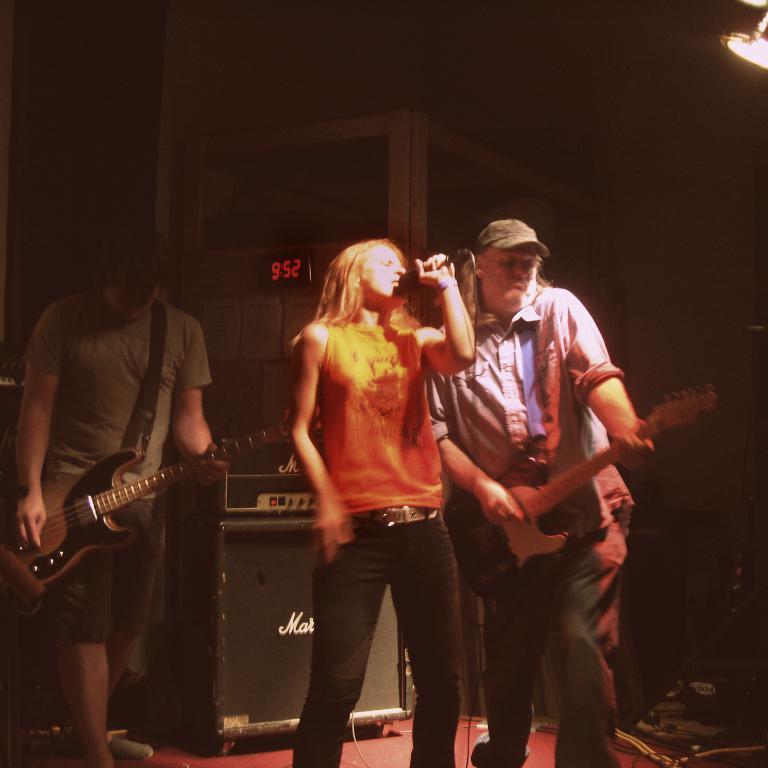Please provide a concise description of this image. There are three members in this picture. Two of them were men who are playing guitars in their hands and the another one is woman who is singing with a mic in her hand. In the background there is a wall. 